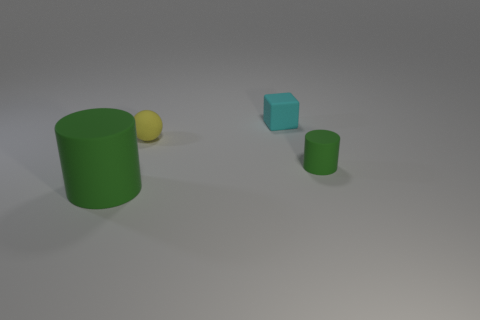How many objects are there, and can you describe their arrangement? There are four objects in the image: a yellow sphere, a small cyan cube, and two green cylinders of different sizes. They are spaced apart on a flat surface, each object isolated from the others, creating a simplistic and spaced out arrangement. Could you guess the purpose of this arrangement, or is it random? The purpose is not clear from the image alone. It might be an abstract composition meant for aesthetic purposes, a demonstration of 3D modeling, or a setup for some physics demonstrations. Without additional context, determining the purpose is largely speculative. 